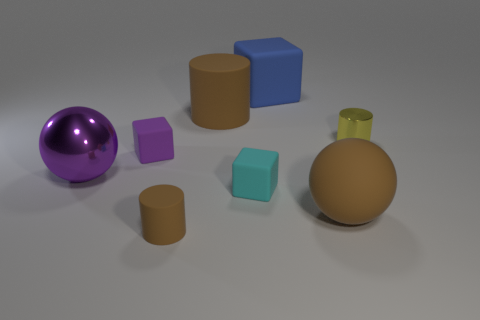Is there anything else that has the same color as the big cube?
Your answer should be compact. No. There is a thing that is behind the big brown thing behind the yellow thing; what number of tiny cylinders are to the left of it?
Ensure brevity in your answer.  1. The matte cube that is in front of the purple shiny object is what color?
Your response must be concise. Cyan. The thing that is in front of the purple block and to the left of the tiny brown cylinder is made of what material?
Ensure brevity in your answer.  Metal. How many large brown rubber cylinders are in front of the sphere on the right side of the tiny cyan cube?
Provide a succinct answer. 0. The small yellow thing has what shape?
Give a very brief answer. Cylinder. There is a tiny yellow object that is the same material as the purple sphere; what shape is it?
Make the answer very short. Cylinder. Does the large matte object right of the blue object have the same shape as the big purple thing?
Ensure brevity in your answer.  Yes. The metallic object in front of the yellow metallic object has what shape?
Ensure brevity in your answer.  Sphere. What is the shape of the tiny object that is the same color as the large shiny thing?
Your answer should be very brief. Cube. 